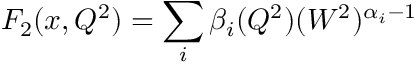Convert formula to latex. <formula><loc_0><loc_0><loc_500><loc_500>F _ { 2 } ( x , Q ^ { 2 } ) = \sum _ { i } \beta _ { i } ( Q ^ { 2 } ) ( W ^ { 2 } ) ^ { \alpha _ { i } - 1 }</formula> 